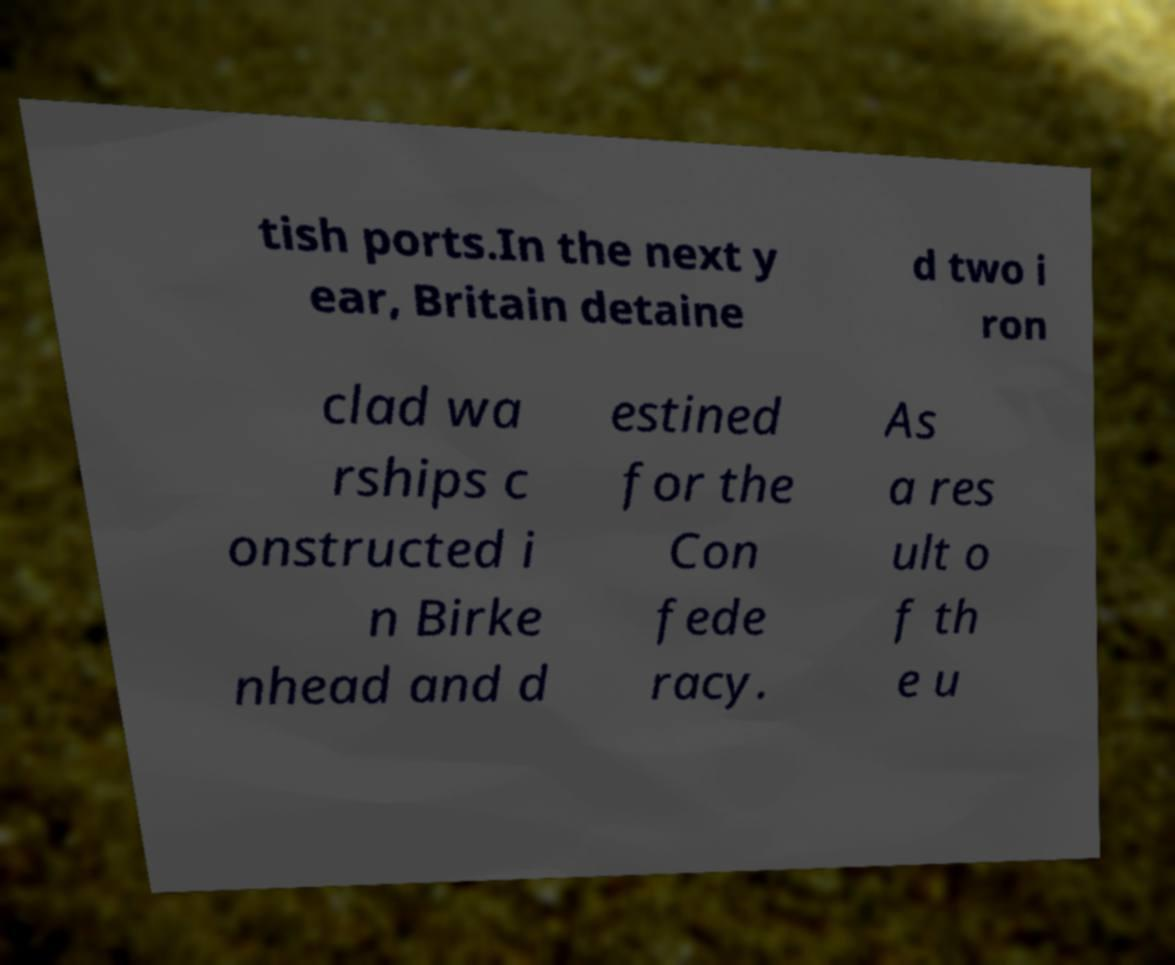Could you assist in decoding the text presented in this image and type it out clearly? tish ports.In the next y ear, Britain detaine d two i ron clad wa rships c onstructed i n Birke nhead and d estined for the Con fede racy. As a res ult o f th e u 